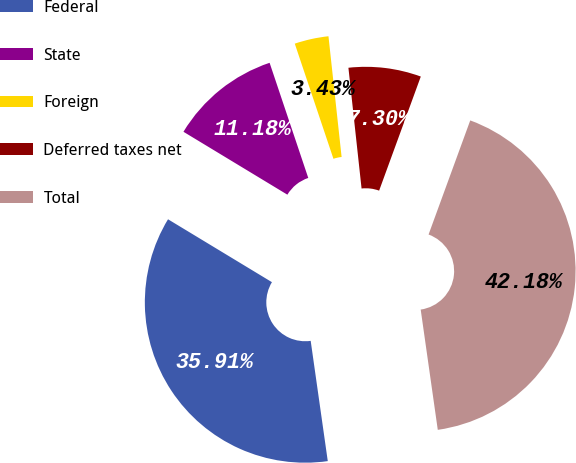<chart> <loc_0><loc_0><loc_500><loc_500><pie_chart><fcel>Federal<fcel>State<fcel>Foreign<fcel>Deferred taxes net<fcel>Total<nl><fcel>35.91%<fcel>11.18%<fcel>3.43%<fcel>7.3%<fcel>42.18%<nl></chart> 